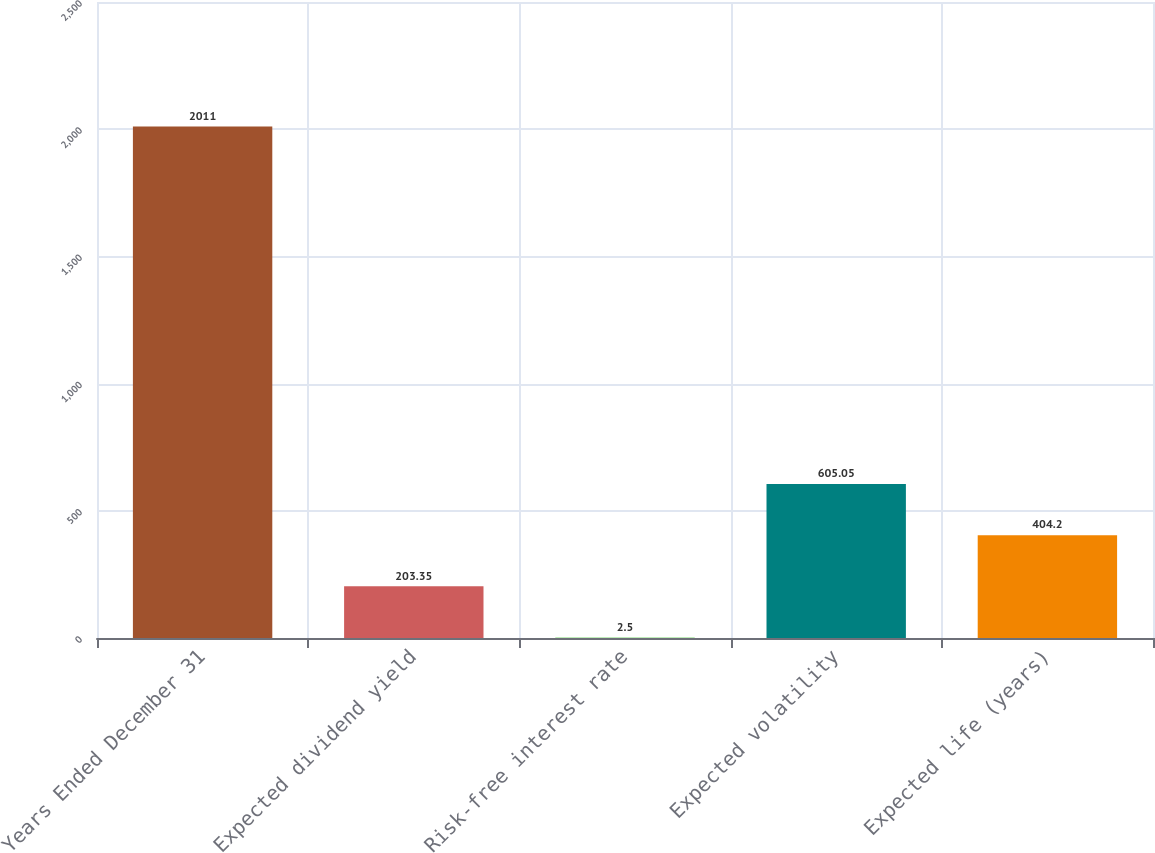Convert chart. <chart><loc_0><loc_0><loc_500><loc_500><bar_chart><fcel>Years Ended December 31<fcel>Expected dividend yield<fcel>Risk-free interest rate<fcel>Expected volatility<fcel>Expected life (years)<nl><fcel>2011<fcel>203.35<fcel>2.5<fcel>605.05<fcel>404.2<nl></chart> 